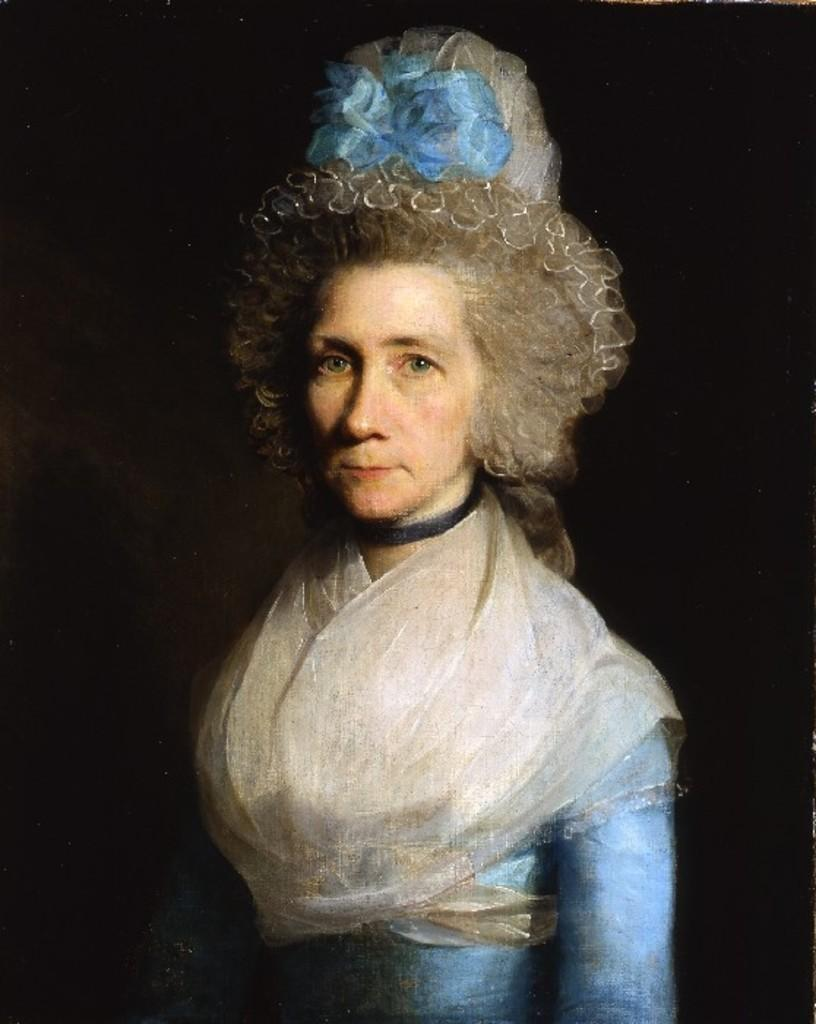What is depicted in the painting in the image? There is a painting of a woman in the image. What is the woman wearing in the painting? The woman is wearing a blue dress and a hat. How would you describe the overall color scheme of the image? The background of the image is dark. What type of power source is used to light up the painting in the image? There is no indication in the image that the painting is lit up or requires a power source. How many thumbs can be seen on the woman's hands in the painting? The image does not show the woman's hands, so it is impossible to determine the number of thumbs. 